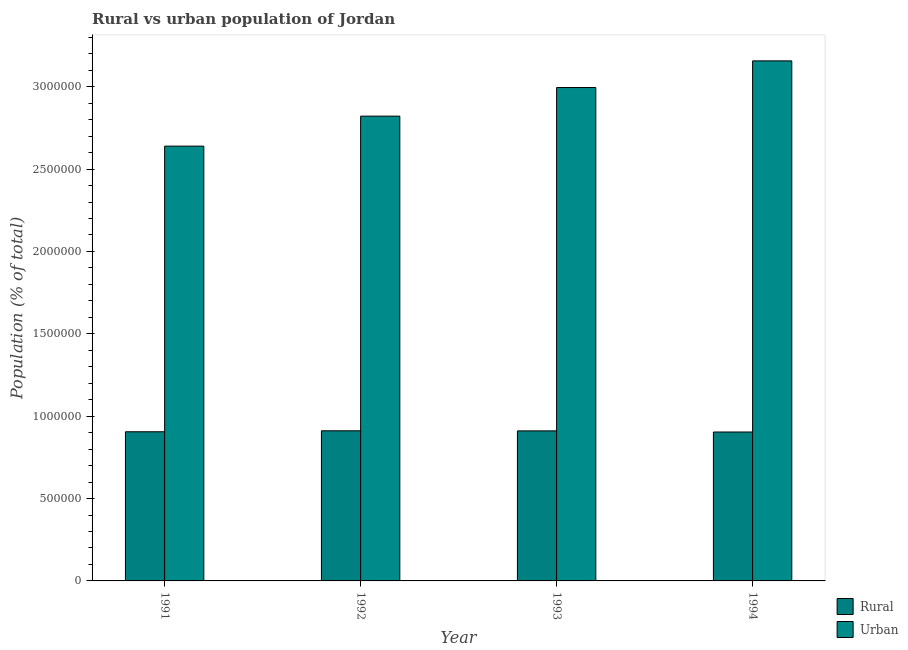How many groups of bars are there?
Provide a succinct answer. 4. Are the number of bars per tick equal to the number of legend labels?
Offer a very short reply. Yes. Are the number of bars on each tick of the X-axis equal?
Keep it short and to the point. Yes. How many bars are there on the 2nd tick from the left?
Give a very brief answer. 2. How many bars are there on the 4th tick from the right?
Offer a terse response. 2. What is the rural population density in 1993?
Provide a succinct answer. 9.11e+05. Across all years, what is the maximum urban population density?
Your answer should be very brief. 3.16e+06. Across all years, what is the minimum urban population density?
Keep it short and to the point. 2.64e+06. In which year was the rural population density maximum?
Your answer should be very brief. 1992. What is the total rural population density in the graph?
Give a very brief answer. 3.63e+06. What is the difference between the rural population density in 1991 and that in 1992?
Keep it short and to the point. -5805. What is the difference between the rural population density in 1991 and the urban population density in 1993?
Provide a short and direct response. -5309. What is the average rural population density per year?
Give a very brief answer. 9.08e+05. In how many years, is the rural population density greater than 500000 %?
Provide a short and direct response. 4. What is the ratio of the rural population density in 1991 to that in 1993?
Offer a very short reply. 0.99. Is the difference between the urban population density in 1993 and 1994 greater than the difference between the rural population density in 1993 and 1994?
Make the answer very short. No. What is the difference between the highest and the second highest urban population density?
Your response must be concise. 1.62e+05. What is the difference between the highest and the lowest rural population density?
Provide a short and direct response. 7396. In how many years, is the urban population density greater than the average urban population density taken over all years?
Ensure brevity in your answer.  2. What does the 1st bar from the left in 1991 represents?
Give a very brief answer. Rural. What does the 1st bar from the right in 1992 represents?
Ensure brevity in your answer.  Urban. Are all the bars in the graph horizontal?
Your answer should be very brief. No. Are the values on the major ticks of Y-axis written in scientific E-notation?
Make the answer very short. No. Does the graph contain any zero values?
Keep it short and to the point. No. Does the graph contain grids?
Give a very brief answer. No. How many legend labels are there?
Your answer should be very brief. 2. What is the title of the graph?
Your answer should be very brief. Rural vs urban population of Jordan. What is the label or title of the Y-axis?
Offer a terse response. Population (% of total). What is the Population (% of total) of Rural in 1991?
Provide a succinct answer. 9.06e+05. What is the Population (% of total) in Urban in 1991?
Offer a terse response. 2.64e+06. What is the Population (% of total) in Rural in 1992?
Provide a succinct answer. 9.11e+05. What is the Population (% of total) of Urban in 1992?
Give a very brief answer. 2.82e+06. What is the Population (% of total) in Rural in 1993?
Provide a short and direct response. 9.11e+05. What is the Population (% of total) of Urban in 1993?
Keep it short and to the point. 3.00e+06. What is the Population (% of total) of Rural in 1994?
Offer a very short reply. 9.04e+05. What is the Population (% of total) in Urban in 1994?
Your response must be concise. 3.16e+06. Across all years, what is the maximum Population (% of total) of Rural?
Your response must be concise. 9.11e+05. Across all years, what is the maximum Population (% of total) in Urban?
Make the answer very short. 3.16e+06. Across all years, what is the minimum Population (% of total) in Rural?
Make the answer very short. 9.04e+05. Across all years, what is the minimum Population (% of total) in Urban?
Keep it short and to the point. 2.64e+06. What is the total Population (% of total) in Rural in the graph?
Your response must be concise. 3.63e+06. What is the total Population (% of total) in Urban in the graph?
Keep it short and to the point. 1.16e+07. What is the difference between the Population (% of total) of Rural in 1991 and that in 1992?
Offer a very short reply. -5805. What is the difference between the Population (% of total) of Urban in 1991 and that in 1992?
Keep it short and to the point. -1.82e+05. What is the difference between the Population (% of total) in Rural in 1991 and that in 1993?
Give a very brief answer. -5309. What is the difference between the Population (% of total) of Urban in 1991 and that in 1993?
Keep it short and to the point. -3.56e+05. What is the difference between the Population (% of total) in Rural in 1991 and that in 1994?
Provide a succinct answer. 1591. What is the difference between the Population (% of total) of Urban in 1991 and that in 1994?
Keep it short and to the point. -5.18e+05. What is the difference between the Population (% of total) of Rural in 1992 and that in 1993?
Ensure brevity in your answer.  496. What is the difference between the Population (% of total) in Urban in 1992 and that in 1993?
Your answer should be very brief. -1.73e+05. What is the difference between the Population (% of total) in Rural in 1992 and that in 1994?
Ensure brevity in your answer.  7396. What is the difference between the Population (% of total) of Urban in 1992 and that in 1994?
Your answer should be compact. -3.35e+05. What is the difference between the Population (% of total) in Rural in 1993 and that in 1994?
Provide a short and direct response. 6900. What is the difference between the Population (% of total) of Urban in 1993 and that in 1994?
Make the answer very short. -1.62e+05. What is the difference between the Population (% of total) in Rural in 1991 and the Population (% of total) in Urban in 1992?
Your answer should be very brief. -1.92e+06. What is the difference between the Population (% of total) of Rural in 1991 and the Population (% of total) of Urban in 1993?
Offer a terse response. -2.09e+06. What is the difference between the Population (% of total) of Rural in 1991 and the Population (% of total) of Urban in 1994?
Your answer should be compact. -2.25e+06. What is the difference between the Population (% of total) of Rural in 1992 and the Population (% of total) of Urban in 1993?
Ensure brevity in your answer.  -2.08e+06. What is the difference between the Population (% of total) in Rural in 1992 and the Population (% of total) in Urban in 1994?
Make the answer very short. -2.25e+06. What is the difference between the Population (% of total) of Rural in 1993 and the Population (% of total) of Urban in 1994?
Your response must be concise. -2.25e+06. What is the average Population (% of total) of Rural per year?
Offer a very short reply. 9.08e+05. What is the average Population (% of total) in Urban per year?
Your answer should be compact. 2.90e+06. In the year 1991, what is the difference between the Population (% of total) of Rural and Population (% of total) of Urban?
Keep it short and to the point. -1.73e+06. In the year 1992, what is the difference between the Population (% of total) in Rural and Population (% of total) in Urban?
Your answer should be compact. -1.91e+06. In the year 1993, what is the difference between the Population (% of total) of Rural and Population (% of total) of Urban?
Your answer should be very brief. -2.08e+06. In the year 1994, what is the difference between the Population (% of total) in Rural and Population (% of total) in Urban?
Offer a terse response. -2.25e+06. What is the ratio of the Population (% of total) of Urban in 1991 to that in 1992?
Provide a short and direct response. 0.94. What is the ratio of the Population (% of total) in Urban in 1991 to that in 1993?
Give a very brief answer. 0.88. What is the ratio of the Population (% of total) in Urban in 1991 to that in 1994?
Make the answer very short. 0.84. What is the ratio of the Population (% of total) of Rural in 1992 to that in 1993?
Provide a short and direct response. 1. What is the ratio of the Population (% of total) of Urban in 1992 to that in 1993?
Make the answer very short. 0.94. What is the ratio of the Population (% of total) of Rural in 1992 to that in 1994?
Your answer should be compact. 1.01. What is the ratio of the Population (% of total) of Urban in 1992 to that in 1994?
Give a very brief answer. 0.89. What is the ratio of the Population (% of total) of Rural in 1993 to that in 1994?
Ensure brevity in your answer.  1.01. What is the ratio of the Population (% of total) of Urban in 1993 to that in 1994?
Your answer should be very brief. 0.95. What is the difference between the highest and the second highest Population (% of total) of Rural?
Keep it short and to the point. 496. What is the difference between the highest and the second highest Population (% of total) in Urban?
Make the answer very short. 1.62e+05. What is the difference between the highest and the lowest Population (% of total) of Rural?
Offer a terse response. 7396. What is the difference between the highest and the lowest Population (% of total) in Urban?
Your answer should be compact. 5.18e+05. 